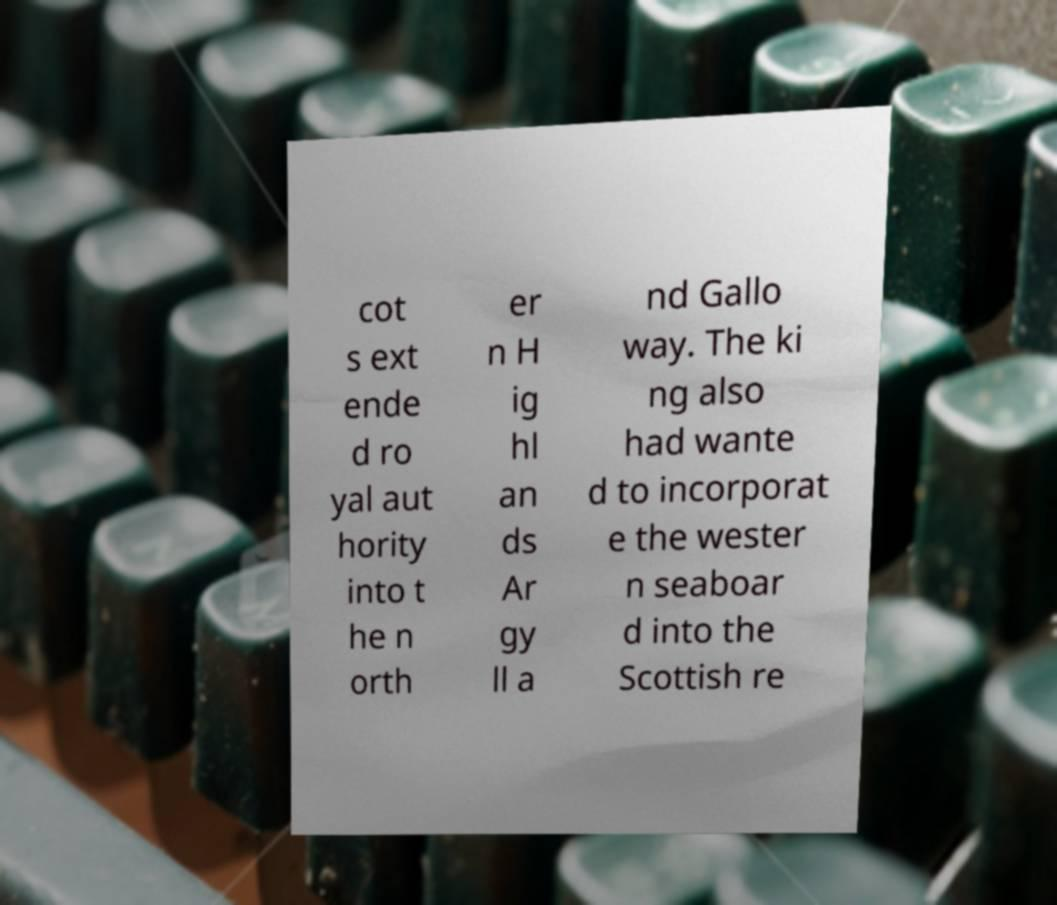I need the written content from this picture converted into text. Can you do that? cot s ext ende d ro yal aut hority into t he n orth er n H ig hl an ds Ar gy ll a nd Gallo way. The ki ng also had wante d to incorporat e the wester n seaboar d into the Scottish re 